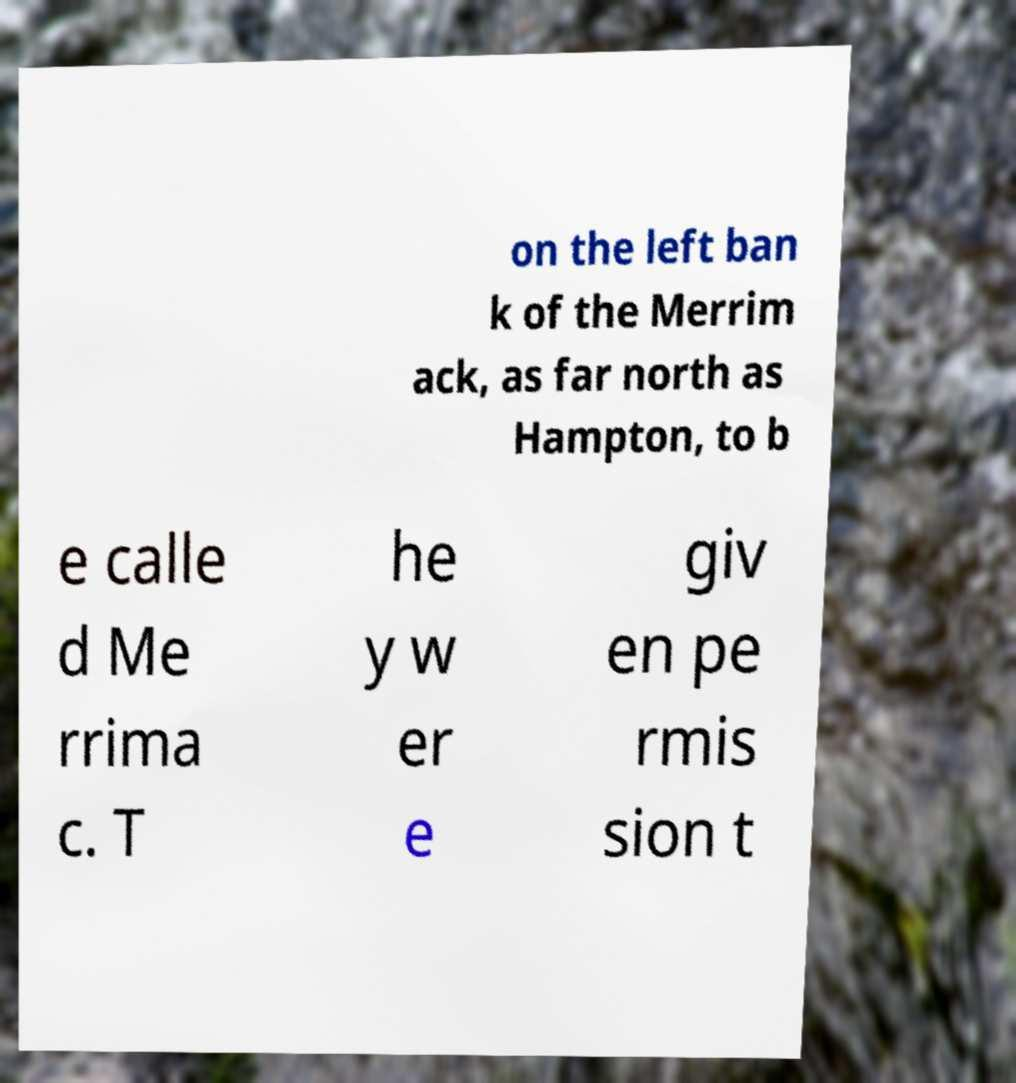Please identify and transcribe the text found in this image. on the left ban k of the Merrim ack, as far north as Hampton, to b e calle d Me rrima c. T he y w er e giv en pe rmis sion t 